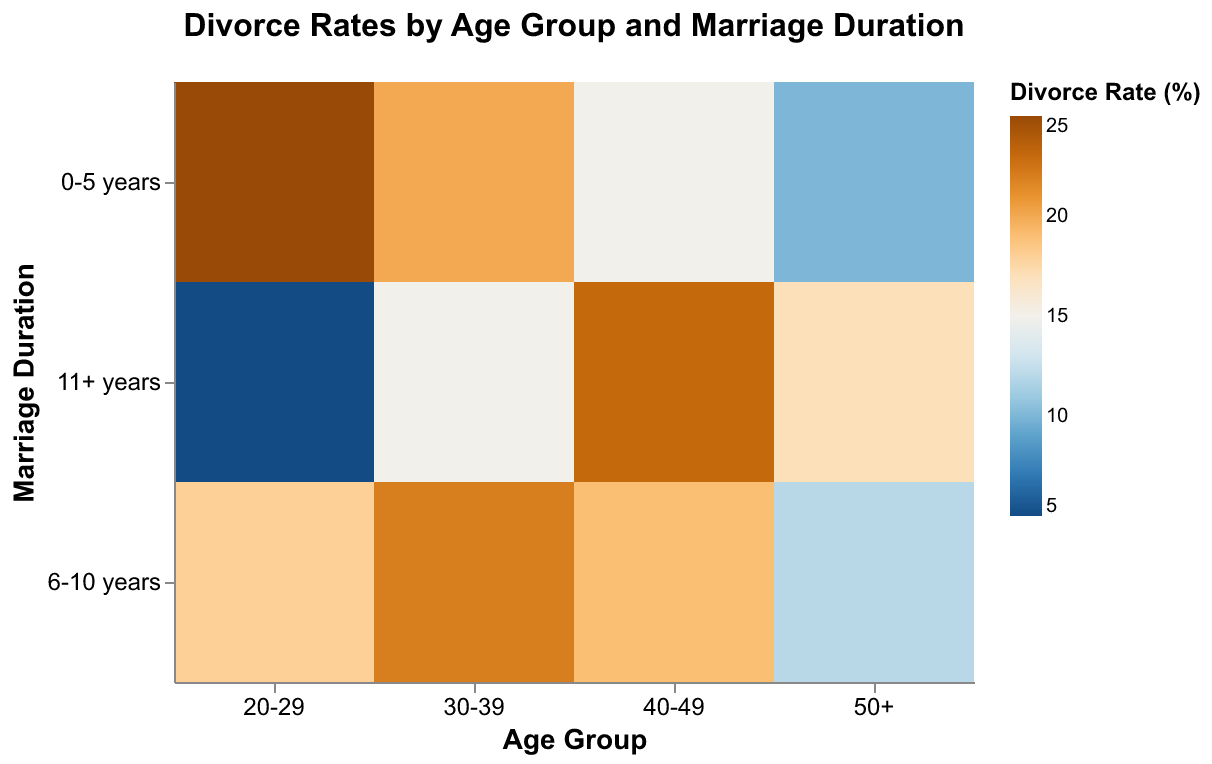What does the title of the figure indicate? The title of the figure is placed at the top and reads "Divorce Rates by Age Group and Marriage Duration." It indicates that the figure is measuring and comparing the divorce rates based on different age groups and the duration of marriage.
Answer: Divorce Rates by Age Group and Marriage Duration Which age group has the highest divorce rate for marriages lasting 0-5 years? Refer to the color scale that represents divorce rates and find the darkest rectangle within the row labeled "0-5 years." In this row, the "20-29" age group has the darkest color.
Answer: 20-29 Which marriage duration category in the 40-49 age group has the lowest divorce rate? Look at the columns under the "40-49" age group and compare the colors across different marriage duration categories. The lightest color in this group appears in the "0-5 years" category.
Answer: 0-5 years What is the divorce rate for marriages lasting 11+ years in the 50+ age group? Locate the intersection of the row labeled "11+ years" and the column labeled "50+" age group. The color intensity at this intersection corresponds to a divorce rate of 17%.
Answer: 17% Which marriage duration category in the 30-39 age group has the highest divorce rate? Within the columns under the "30-39" age group, compare the color intensities of the rows. The darkest color indicating the highest divorce rate appears in the "6-10 years" category.
Answer: 6-10 years Is the divorce rate generally higher for shorter or longer marriages within each age group? You need to look at the trend within each age group's column. Generally, darker shades indicate higher divorce rates. For most age groups, except for the "50+" group, the "0-5 years" category usually shows darker colors compared to the "11+ years" category, indicating higher divorce rates for shorter marriages.
Answer: Shorter marriages How does the divorce rate for marriages lasting 6-10 years compare across age groups? Compare the middle rows across all age groups. Observe the shades from "20-29" to "50+." The intensity of the color generally decreases as the age group increases, meaning the divorce rate decreases from younger to older age groups.
Answer: Decreases with age Among the 50+ age group, how does the divorce rate change as the duration of marriage increases? Look at the shades of the "50+" group and compare the colors from top to bottom. The colors transition from lighter to darker, indicating an increasing divorce rate as the duration of marriage increases.
Answer: Increases with marriage duration Which age group has the most significant change in divorce rates between the "0-5 years" and "6-10 years" categories? Compare the differences in color intensity between the first and second rows within each age group. The "20-29" age group shows a notable change from a very dark to a much lighter shade, indicating a significant drop in divorce rates.
Answer: 20-29 What is the overall trend in divorce rates as age increases, regardless of marriage duration? By observing the columns as a whole, it is evident that the overall color intensity tends to lighten as the age groups increase from "20-29" to "50+," indicating lower divorce rates in older age groups.
Answer: Decreases with age 